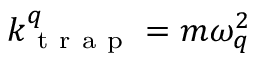Convert formula to latex. <formula><loc_0><loc_0><loc_500><loc_500>k _ { t r a p } ^ { q } = m \omega _ { q } ^ { 2 }</formula> 